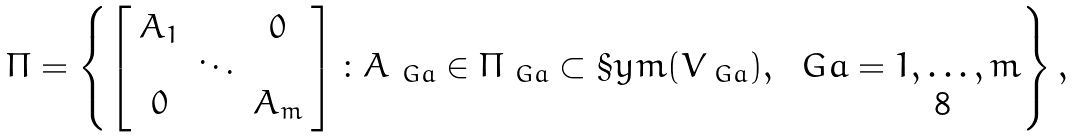Convert formula to latex. <formula><loc_0><loc_0><loc_500><loc_500>\Pi = \left \{ \left [ \begin{array} { c c c } A _ { 1 } & & 0 \\ & \ddots & \\ 0 & & A _ { m } \end{array} \right ] \colon A _ { \ G a } \in \Pi _ { \ G a } \subset \S y m ( V _ { \ G a } ) , \ \ G a = 1 , \dots , m \right \} ,</formula> 